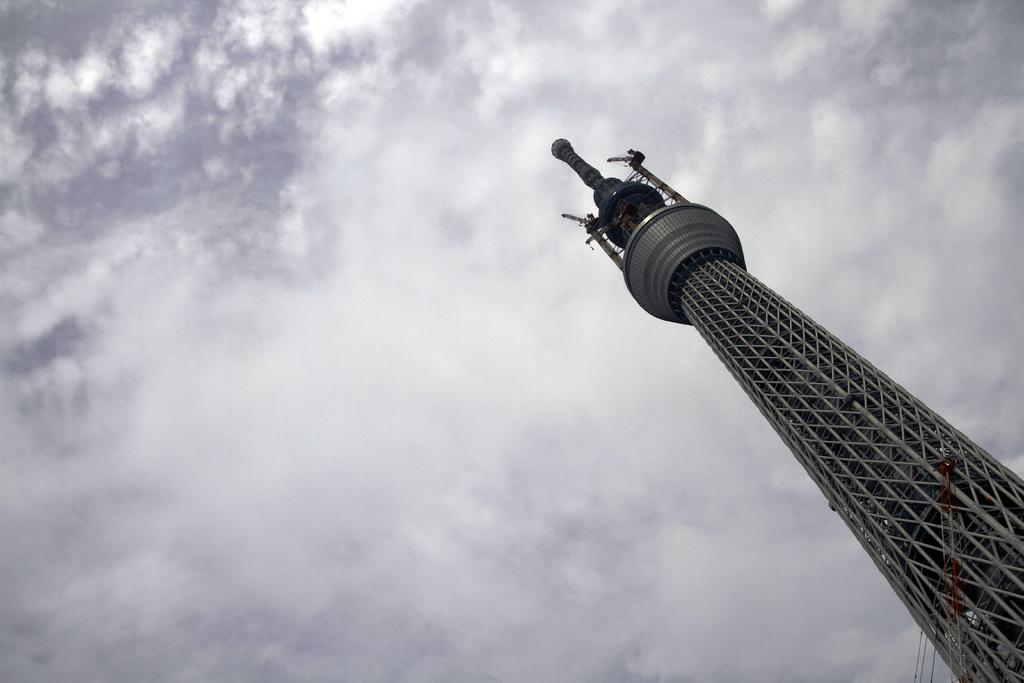What is the main subject of the picture? The main subject of the picture is a tower. What can be seen in the background of the picture? The sky is visible in the background of the picture. What is the condition of the sky in the picture? Clouds are present in the sky. What type of pail is being used by the carpenter in the picture? There is no carpenter or pail present in the image; it features a tower and clouds in the sky. How does the digestion process of the tower appear in the image? The tower is an inanimate object and does not have a digestion process. 